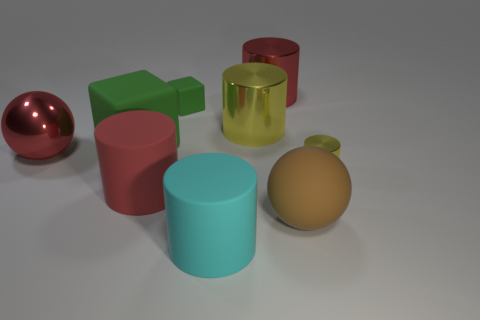Subtract all big cylinders. How many cylinders are left? 1 Subtract all green cubes. How many yellow cylinders are left? 2 Subtract 1 cylinders. How many cylinders are left? 4 Subtract all red cylinders. How many cylinders are left? 3 Subtract all spheres. How many objects are left? 7 Add 1 small gray metal blocks. How many objects exist? 10 Subtract all blue cylinders. Subtract all green cubes. How many cylinders are left? 5 Subtract all large metallic spheres. Subtract all big red matte cylinders. How many objects are left? 7 Add 6 tiny green matte blocks. How many tiny green matte blocks are left? 7 Add 9 blue metal cylinders. How many blue metal cylinders exist? 9 